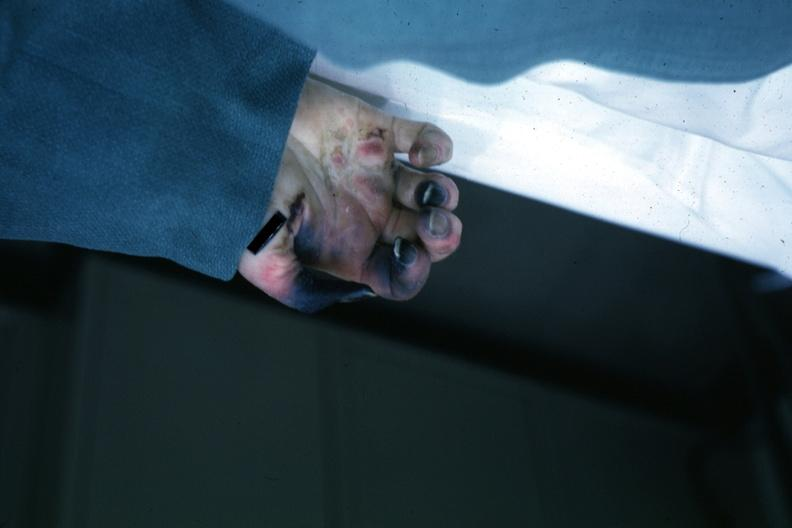s gangrene fingers present?
Answer the question using a single word or phrase. Yes 